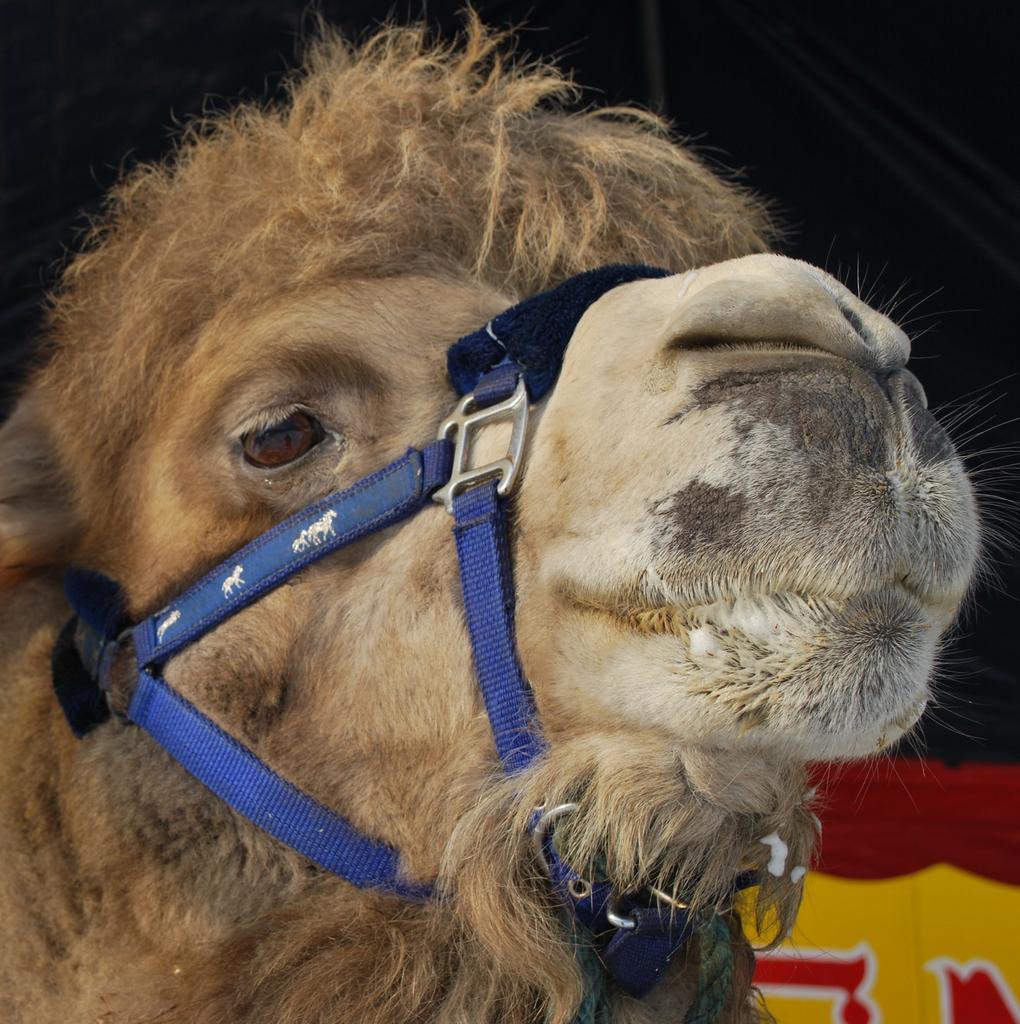How would you summarize this image in a sentence or two? In this image we can see an animal. 